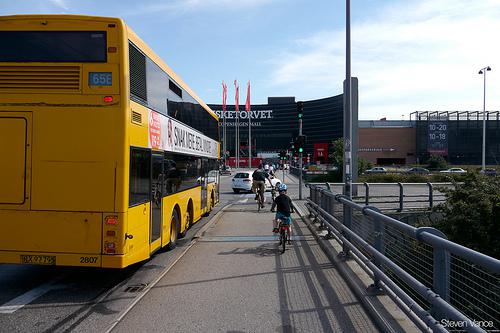Question: what is on the left?
Choices:
A. Tree.
B. Man on a bicycle.
C. Bus.
D. Motorcycle.
Answer with the letter. Answer: C Question: where is the traffic light?
Choices:
A. On the ground.
B. At the corner.
C. On the roundabout.
D. In the truck.
Answer with the letter. Answer: B Question: why are the people wearing helmets?
Choices:
A. Accident prevention.
B. Safety.
C. Peace of mind.
D. City ordinance.
Answer with the letter. Answer: B Question: how are the flags displayed?
Choices:
A. In the window.
B. Top of flagpoles.
C. Attached to side of building.
D. Someone is holding it.
Answer with the letter. Answer: B Question: what kind of bus is this?
Choices:
A. Electric hybrid.
B. Double decker.
C. Commuter Bus.
D. School bus.
Answer with the letter. Answer: B 